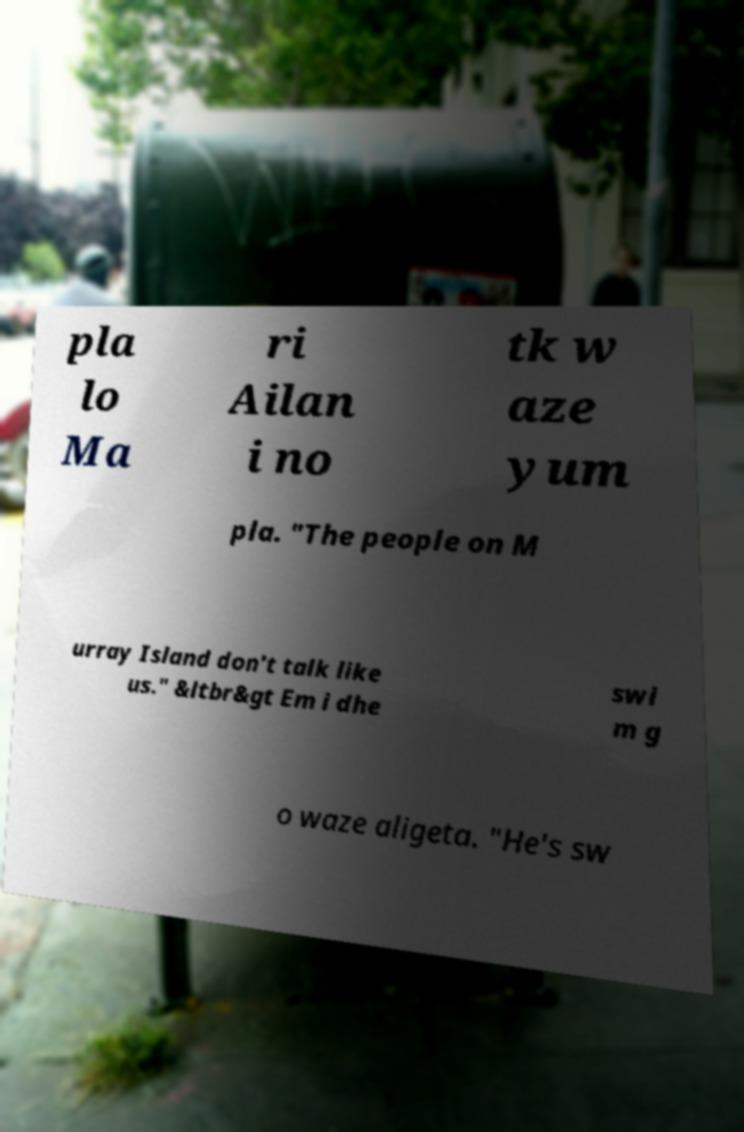I need the written content from this picture converted into text. Can you do that? pla lo Ma ri Ailan i no tk w aze yum pla. "The people on M urray Island don't talk like us." &ltbr&gt Em i dhe swi m g o waze aligeta. "He's sw 